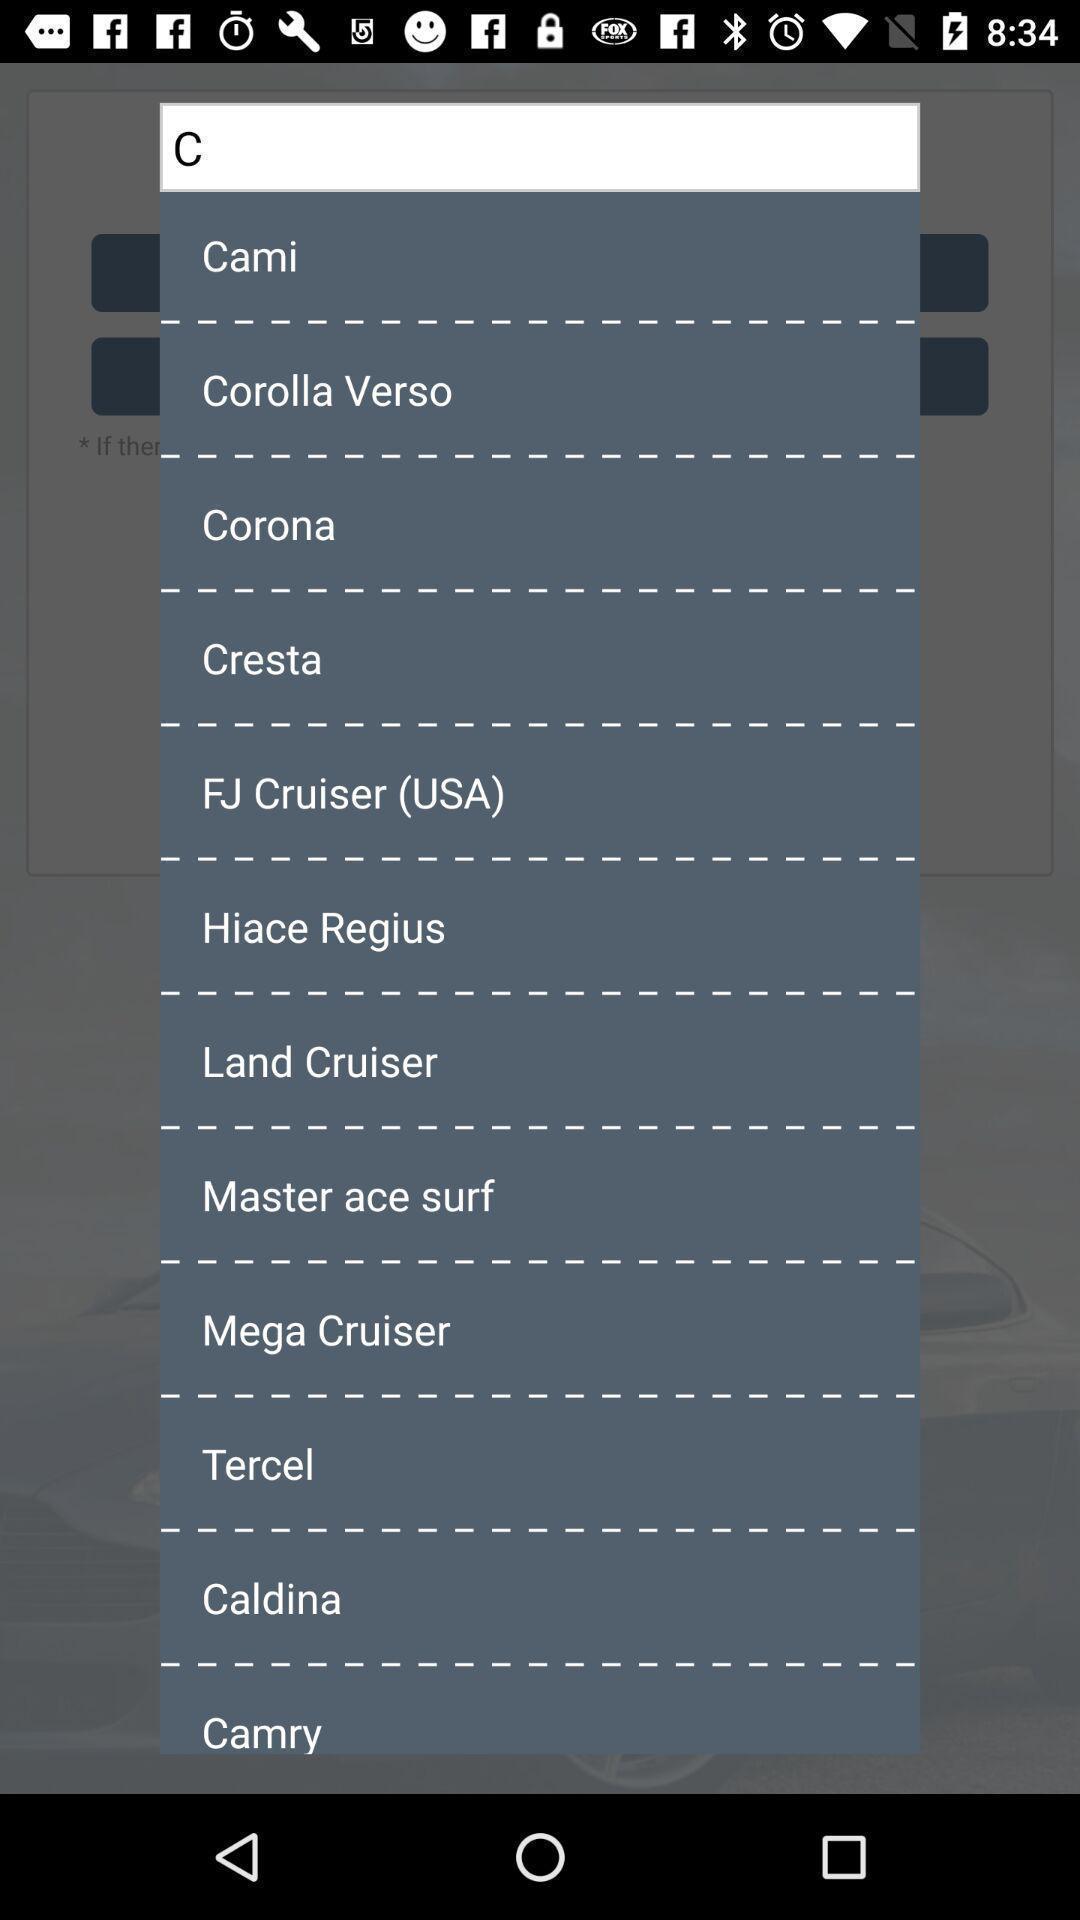What is the overall content of this screenshot? Popup of different kinds of cars in the application. 